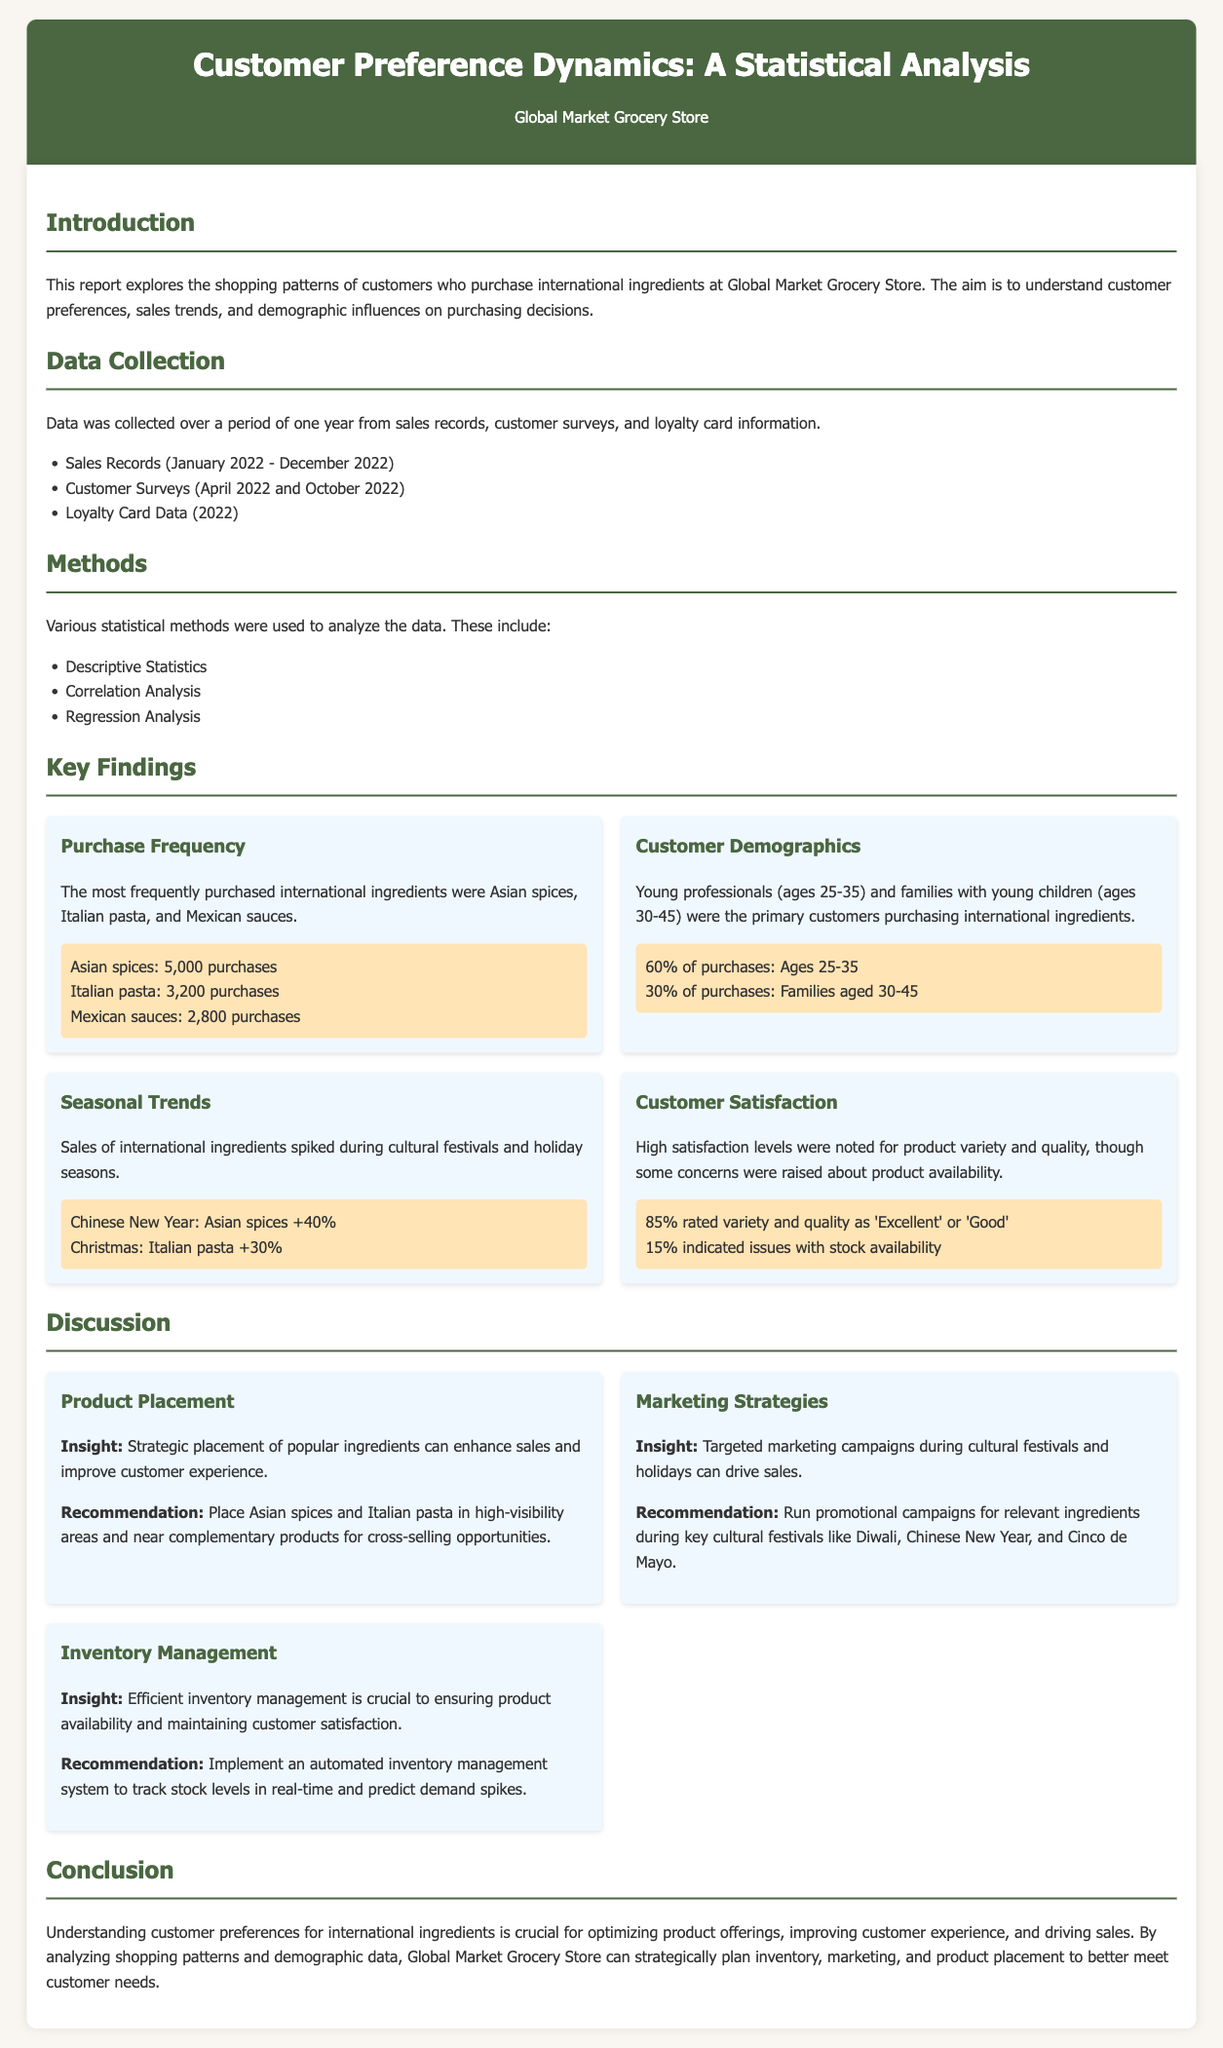What were the most frequently purchased international ingredients? The most frequently purchased ingredients listed in the document include Asian spices, Italian pasta, and Mexican sauces.
Answer: Asian spices, Italian pasta, Mexican sauces How many purchases were recorded for Asian spices? The document states the number of purchases for Asian spices specifically as 5,000.
Answer: 5,000 What percentage of purchases were made by customers aged 25-35? According to the findings, 60% of purchases were attributed to customers aged 25-35.
Answer: 60% What was the sales increase for Asian spices during Chinese New Year? The report indicates that sales of Asian spices increased by 40% during this event.
Answer: 40% What was the customer satisfaction rating for product variety and quality? The satisfaction levels for variety and quality were noted as 85% rated them 'Excellent' or 'Good'.
Answer: 85% What marketing strategy is recommended for cultural festivals? The recommendation is to run promotional campaigns for relevant ingredients during cultural festivals.
Answer: Run promotional campaigns What insight is given regarding product placement? The report states that strategic placement of popular ingredients can enhance sales and improve customer experience.
Answer: Strategic placement What issue was indicated by 15% of customers? The concerns raised by this percentage pertained specifically to product availability.
Answer: Product availability What method was used in the analysis of customer preferences? The document mentions that correlation analysis was one of the methods employed to understand shopping patterns.
Answer: Correlation Analysis 